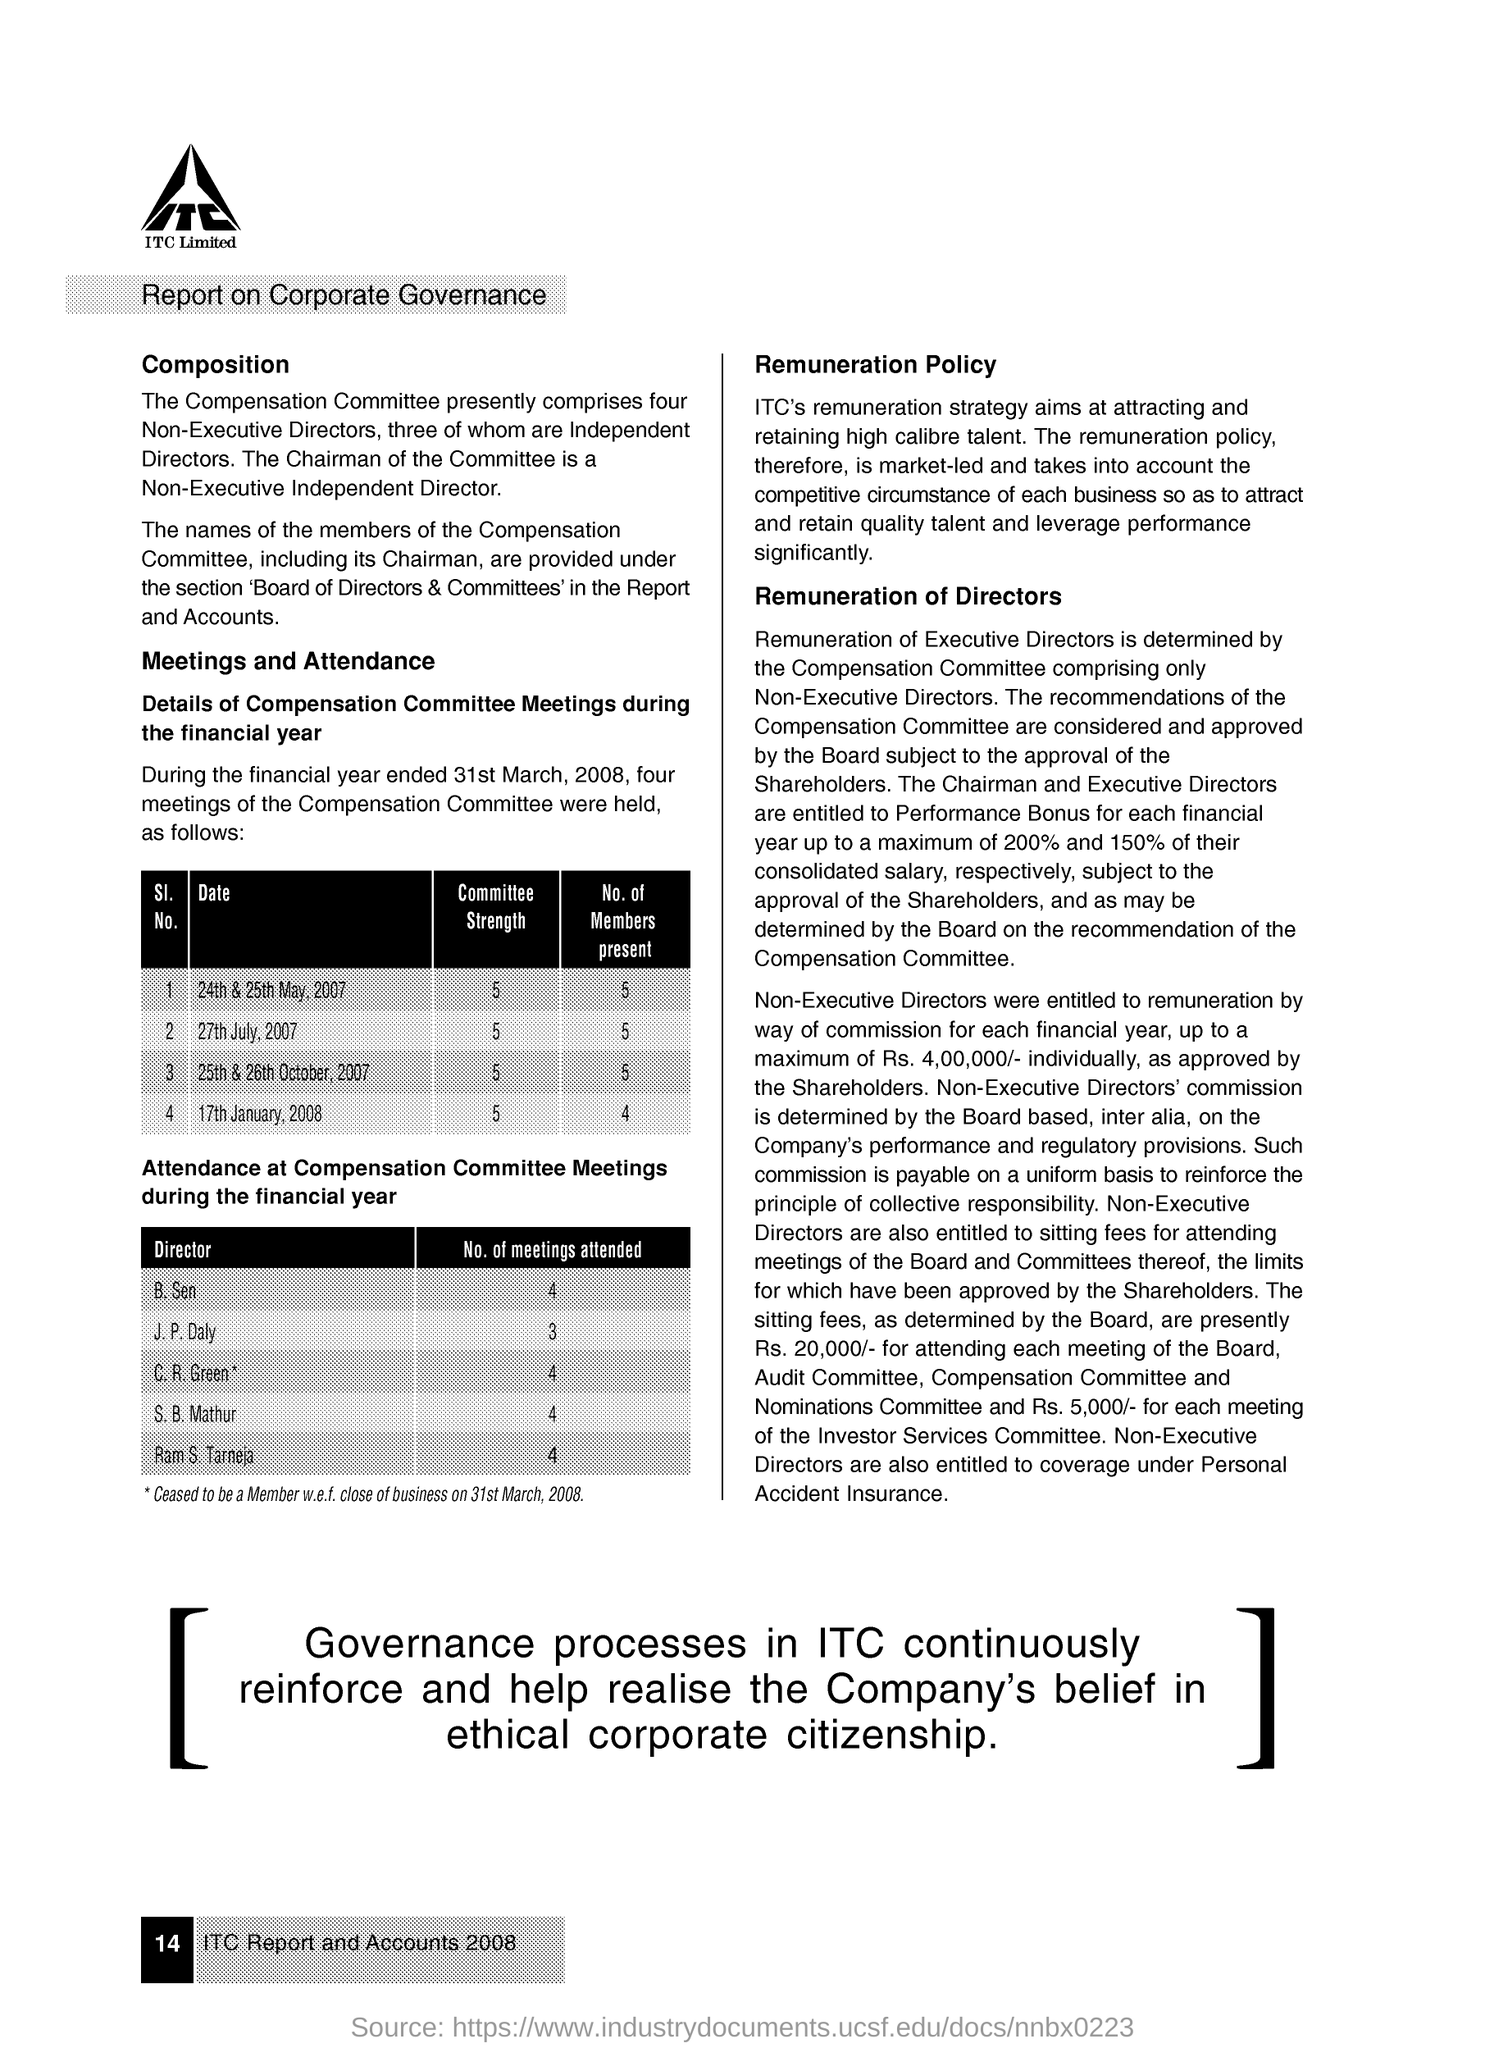Outline some significant characteristics in this image. The number of meetings attended by S.B. Mathur is 4. On January 17th, 2008, there were 4 members present. B. Sen attended 4 meetings. There were five members present on July 27, 2007. J.P. Daly attended three meetings. 